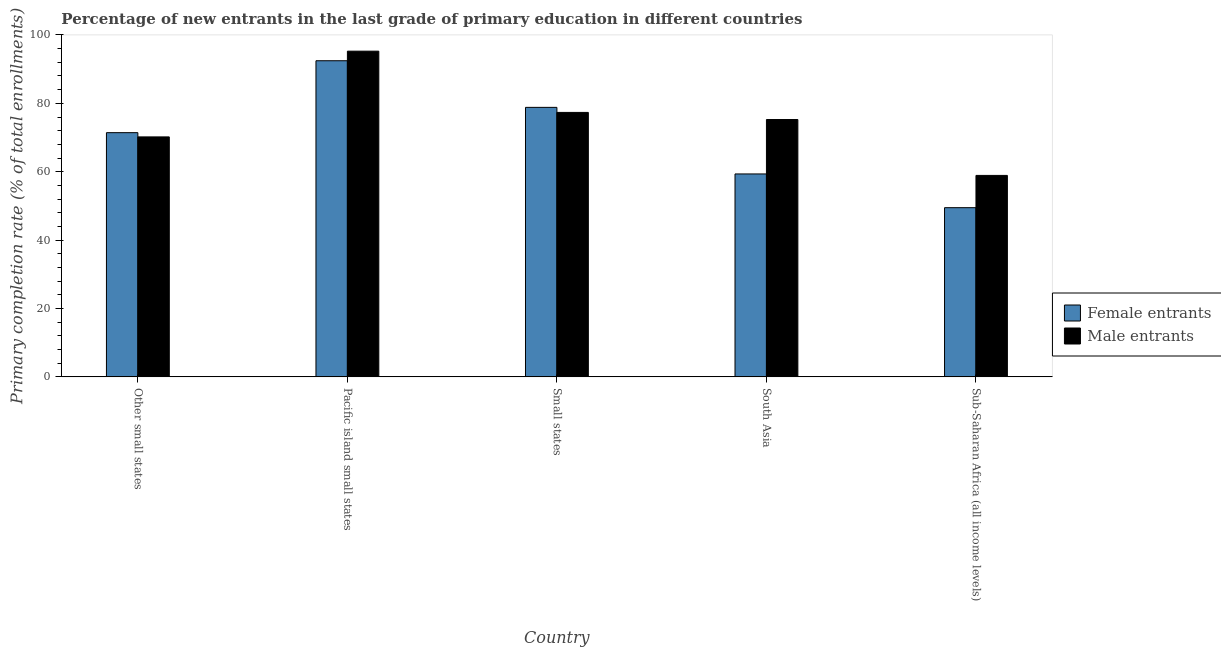How many different coloured bars are there?
Make the answer very short. 2. How many groups of bars are there?
Make the answer very short. 5. Are the number of bars per tick equal to the number of legend labels?
Keep it short and to the point. Yes. How many bars are there on the 1st tick from the left?
Your response must be concise. 2. How many bars are there on the 2nd tick from the right?
Provide a succinct answer. 2. What is the label of the 3rd group of bars from the left?
Offer a terse response. Small states. In how many cases, is the number of bars for a given country not equal to the number of legend labels?
Offer a very short reply. 0. What is the primary completion rate of male entrants in Other small states?
Offer a very short reply. 70.18. Across all countries, what is the maximum primary completion rate of male entrants?
Keep it short and to the point. 95.26. Across all countries, what is the minimum primary completion rate of male entrants?
Your answer should be very brief. 58.92. In which country was the primary completion rate of male entrants maximum?
Your response must be concise. Pacific island small states. In which country was the primary completion rate of female entrants minimum?
Provide a succinct answer. Sub-Saharan Africa (all income levels). What is the total primary completion rate of female entrants in the graph?
Ensure brevity in your answer.  351.53. What is the difference between the primary completion rate of female entrants in Other small states and that in Small states?
Make the answer very short. -7.39. What is the difference between the primary completion rate of female entrants in Small states and the primary completion rate of male entrants in Pacific island small states?
Your answer should be compact. -16.44. What is the average primary completion rate of male entrants per country?
Your answer should be compact. 75.39. What is the difference between the primary completion rate of male entrants and primary completion rate of female entrants in Other small states?
Ensure brevity in your answer.  -1.24. What is the ratio of the primary completion rate of male entrants in Other small states to that in South Asia?
Keep it short and to the point. 0.93. What is the difference between the highest and the second highest primary completion rate of male entrants?
Offer a very short reply. 17.91. What is the difference between the highest and the lowest primary completion rate of male entrants?
Provide a short and direct response. 36.34. In how many countries, is the primary completion rate of female entrants greater than the average primary completion rate of female entrants taken over all countries?
Ensure brevity in your answer.  3. Is the sum of the primary completion rate of female entrants in Other small states and Pacific island small states greater than the maximum primary completion rate of male entrants across all countries?
Your response must be concise. Yes. What does the 1st bar from the left in Small states represents?
Provide a succinct answer. Female entrants. What does the 1st bar from the right in Pacific island small states represents?
Your answer should be very brief. Male entrants. Are all the bars in the graph horizontal?
Provide a short and direct response. No. How many countries are there in the graph?
Your response must be concise. 5. What is the difference between two consecutive major ticks on the Y-axis?
Offer a terse response. 20. Are the values on the major ticks of Y-axis written in scientific E-notation?
Ensure brevity in your answer.  No. Does the graph contain grids?
Your answer should be very brief. No. Where does the legend appear in the graph?
Your answer should be very brief. Center right. How many legend labels are there?
Provide a succinct answer. 2. What is the title of the graph?
Give a very brief answer. Percentage of new entrants in the last grade of primary education in different countries. Does "Under-5(male)" appear as one of the legend labels in the graph?
Provide a succinct answer. No. What is the label or title of the X-axis?
Your answer should be compact. Country. What is the label or title of the Y-axis?
Your answer should be very brief. Primary completion rate (% of total enrollments). What is the Primary completion rate (% of total enrollments) in Female entrants in Other small states?
Ensure brevity in your answer.  71.42. What is the Primary completion rate (% of total enrollments) of Male entrants in Other small states?
Provide a succinct answer. 70.18. What is the Primary completion rate (% of total enrollments) of Female entrants in Pacific island small states?
Ensure brevity in your answer.  92.46. What is the Primary completion rate (% of total enrollments) in Male entrants in Pacific island small states?
Offer a very short reply. 95.26. What is the Primary completion rate (% of total enrollments) in Female entrants in Small states?
Keep it short and to the point. 78.82. What is the Primary completion rate (% of total enrollments) of Male entrants in Small states?
Your response must be concise. 77.35. What is the Primary completion rate (% of total enrollments) of Female entrants in South Asia?
Keep it short and to the point. 59.35. What is the Primary completion rate (% of total enrollments) in Male entrants in South Asia?
Offer a terse response. 75.27. What is the Primary completion rate (% of total enrollments) in Female entrants in Sub-Saharan Africa (all income levels)?
Give a very brief answer. 49.48. What is the Primary completion rate (% of total enrollments) in Male entrants in Sub-Saharan Africa (all income levels)?
Your response must be concise. 58.92. Across all countries, what is the maximum Primary completion rate (% of total enrollments) in Female entrants?
Offer a terse response. 92.46. Across all countries, what is the maximum Primary completion rate (% of total enrollments) in Male entrants?
Ensure brevity in your answer.  95.26. Across all countries, what is the minimum Primary completion rate (% of total enrollments) of Female entrants?
Give a very brief answer. 49.48. Across all countries, what is the minimum Primary completion rate (% of total enrollments) in Male entrants?
Offer a terse response. 58.92. What is the total Primary completion rate (% of total enrollments) in Female entrants in the graph?
Ensure brevity in your answer.  351.53. What is the total Primary completion rate (% of total enrollments) in Male entrants in the graph?
Ensure brevity in your answer.  376.97. What is the difference between the Primary completion rate (% of total enrollments) in Female entrants in Other small states and that in Pacific island small states?
Provide a succinct answer. -21.03. What is the difference between the Primary completion rate (% of total enrollments) in Male entrants in Other small states and that in Pacific island small states?
Ensure brevity in your answer.  -25.08. What is the difference between the Primary completion rate (% of total enrollments) of Female entrants in Other small states and that in Small states?
Give a very brief answer. -7.39. What is the difference between the Primary completion rate (% of total enrollments) in Male entrants in Other small states and that in Small states?
Provide a succinct answer. -7.16. What is the difference between the Primary completion rate (% of total enrollments) of Female entrants in Other small states and that in South Asia?
Your answer should be compact. 12.08. What is the difference between the Primary completion rate (% of total enrollments) of Male entrants in Other small states and that in South Asia?
Keep it short and to the point. -5.08. What is the difference between the Primary completion rate (% of total enrollments) in Female entrants in Other small states and that in Sub-Saharan Africa (all income levels)?
Offer a very short reply. 21.94. What is the difference between the Primary completion rate (% of total enrollments) in Male entrants in Other small states and that in Sub-Saharan Africa (all income levels)?
Keep it short and to the point. 11.26. What is the difference between the Primary completion rate (% of total enrollments) in Female entrants in Pacific island small states and that in Small states?
Make the answer very short. 13.64. What is the difference between the Primary completion rate (% of total enrollments) in Male entrants in Pacific island small states and that in Small states?
Your answer should be very brief. 17.91. What is the difference between the Primary completion rate (% of total enrollments) of Female entrants in Pacific island small states and that in South Asia?
Ensure brevity in your answer.  33.11. What is the difference between the Primary completion rate (% of total enrollments) in Male entrants in Pacific island small states and that in South Asia?
Provide a short and direct response. 19.99. What is the difference between the Primary completion rate (% of total enrollments) in Female entrants in Pacific island small states and that in Sub-Saharan Africa (all income levels)?
Your response must be concise. 42.97. What is the difference between the Primary completion rate (% of total enrollments) of Male entrants in Pacific island small states and that in Sub-Saharan Africa (all income levels)?
Provide a short and direct response. 36.34. What is the difference between the Primary completion rate (% of total enrollments) in Female entrants in Small states and that in South Asia?
Offer a very short reply. 19.47. What is the difference between the Primary completion rate (% of total enrollments) in Male entrants in Small states and that in South Asia?
Give a very brief answer. 2.08. What is the difference between the Primary completion rate (% of total enrollments) of Female entrants in Small states and that in Sub-Saharan Africa (all income levels)?
Provide a succinct answer. 29.33. What is the difference between the Primary completion rate (% of total enrollments) in Male entrants in Small states and that in Sub-Saharan Africa (all income levels)?
Make the answer very short. 18.43. What is the difference between the Primary completion rate (% of total enrollments) of Female entrants in South Asia and that in Sub-Saharan Africa (all income levels)?
Your answer should be very brief. 9.86. What is the difference between the Primary completion rate (% of total enrollments) of Male entrants in South Asia and that in Sub-Saharan Africa (all income levels)?
Ensure brevity in your answer.  16.35. What is the difference between the Primary completion rate (% of total enrollments) of Female entrants in Other small states and the Primary completion rate (% of total enrollments) of Male entrants in Pacific island small states?
Ensure brevity in your answer.  -23.84. What is the difference between the Primary completion rate (% of total enrollments) in Female entrants in Other small states and the Primary completion rate (% of total enrollments) in Male entrants in Small states?
Offer a very short reply. -5.92. What is the difference between the Primary completion rate (% of total enrollments) in Female entrants in Other small states and the Primary completion rate (% of total enrollments) in Male entrants in South Asia?
Provide a short and direct response. -3.84. What is the difference between the Primary completion rate (% of total enrollments) of Female entrants in Other small states and the Primary completion rate (% of total enrollments) of Male entrants in Sub-Saharan Africa (all income levels)?
Provide a short and direct response. 12.51. What is the difference between the Primary completion rate (% of total enrollments) in Female entrants in Pacific island small states and the Primary completion rate (% of total enrollments) in Male entrants in Small states?
Make the answer very short. 15.11. What is the difference between the Primary completion rate (% of total enrollments) of Female entrants in Pacific island small states and the Primary completion rate (% of total enrollments) of Male entrants in South Asia?
Offer a terse response. 17.19. What is the difference between the Primary completion rate (% of total enrollments) of Female entrants in Pacific island small states and the Primary completion rate (% of total enrollments) of Male entrants in Sub-Saharan Africa (all income levels)?
Your answer should be compact. 33.54. What is the difference between the Primary completion rate (% of total enrollments) of Female entrants in Small states and the Primary completion rate (% of total enrollments) of Male entrants in South Asia?
Ensure brevity in your answer.  3.55. What is the difference between the Primary completion rate (% of total enrollments) in Female entrants in Small states and the Primary completion rate (% of total enrollments) in Male entrants in Sub-Saharan Africa (all income levels)?
Your answer should be very brief. 19.9. What is the difference between the Primary completion rate (% of total enrollments) in Female entrants in South Asia and the Primary completion rate (% of total enrollments) in Male entrants in Sub-Saharan Africa (all income levels)?
Ensure brevity in your answer.  0.43. What is the average Primary completion rate (% of total enrollments) of Female entrants per country?
Make the answer very short. 70.31. What is the average Primary completion rate (% of total enrollments) in Male entrants per country?
Provide a short and direct response. 75.39. What is the difference between the Primary completion rate (% of total enrollments) in Female entrants and Primary completion rate (% of total enrollments) in Male entrants in Other small states?
Offer a very short reply. 1.24. What is the difference between the Primary completion rate (% of total enrollments) of Female entrants and Primary completion rate (% of total enrollments) of Male entrants in Pacific island small states?
Your answer should be very brief. -2.8. What is the difference between the Primary completion rate (% of total enrollments) of Female entrants and Primary completion rate (% of total enrollments) of Male entrants in Small states?
Offer a very short reply. 1.47. What is the difference between the Primary completion rate (% of total enrollments) of Female entrants and Primary completion rate (% of total enrollments) of Male entrants in South Asia?
Offer a terse response. -15.92. What is the difference between the Primary completion rate (% of total enrollments) of Female entrants and Primary completion rate (% of total enrollments) of Male entrants in Sub-Saharan Africa (all income levels)?
Provide a short and direct response. -9.43. What is the ratio of the Primary completion rate (% of total enrollments) of Female entrants in Other small states to that in Pacific island small states?
Make the answer very short. 0.77. What is the ratio of the Primary completion rate (% of total enrollments) in Male entrants in Other small states to that in Pacific island small states?
Provide a short and direct response. 0.74. What is the ratio of the Primary completion rate (% of total enrollments) in Female entrants in Other small states to that in Small states?
Ensure brevity in your answer.  0.91. What is the ratio of the Primary completion rate (% of total enrollments) in Male entrants in Other small states to that in Small states?
Offer a terse response. 0.91. What is the ratio of the Primary completion rate (% of total enrollments) in Female entrants in Other small states to that in South Asia?
Make the answer very short. 1.2. What is the ratio of the Primary completion rate (% of total enrollments) in Male entrants in Other small states to that in South Asia?
Offer a terse response. 0.93. What is the ratio of the Primary completion rate (% of total enrollments) of Female entrants in Other small states to that in Sub-Saharan Africa (all income levels)?
Ensure brevity in your answer.  1.44. What is the ratio of the Primary completion rate (% of total enrollments) of Male entrants in Other small states to that in Sub-Saharan Africa (all income levels)?
Provide a succinct answer. 1.19. What is the ratio of the Primary completion rate (% of total enrollments) in Female entrants in Pacific island small states to that in Small states?
Your response must be concise. 1.17. What is the ratio of the Primary completion rate (% of total enrollments) of Male entrants in Pacific island small states to that in Small states?
Keep it short and to the point. 1.23. What is the ratio of the Primary completion rate (% of total enrollments) in Female entrants in Pacific island small states to that in South Asia?
Give a very brief answer. 1.56. What is the ratio of the Primary completion rate (% of total enrollments) in Male entrants in Pacific island small states to that in South Asia?
Your answer should be compact. 1.27. What is the ratio of the Primary completion rate (% of total enrollments) in Female entrants in Pacific island small states to that in Sub-Saharan Africa (all income levels)?
Your answer should be very brief. 1.87. What is the ratio of the Primary completion rate (% of total enrollments) in Male entrants in Pacific island small states to that in Sub-Saharan Africa (all income levels)?
Ensure brevity in your answer.  1.62. What is the ratio of the Primary completion rate (% of total enrollments) in Female entrants in Small states to that in South Asia?
Provide a short and direct response. 1.33. What is the ratio of the Primary completion rate (% of total enrollments) of Male entrants in Small states to that in South Asia?
Offer a terse response. 1.03. What is the ratio of the Primary completion rate (% of total enrollments) of Female entrants in Small states to that in Sub-Saharan Africa (all income levels)?
Your response must be concise. 1.59. What is the ratio of the Primary completion rate (% of total enrollments) of Male entrants in Small states to that in Sub-Saharan Africa (all income levels)?
Keep it short and to the point. 1.31. What is the ratio of the Primary completion rate (% of total enrollments) of Female entrants in South Asia to that in Sub-Saharan Africa (all income levels)?
Keep it short and to the point. 1.2. What is the ratio of the Primary completion rate (% of total enrollments) in Male entrants in South Asia to that in Sub-Saharan Africa (all income levels)?
Your answer should be compact. 1.28. What is the difference between the highest and the second highest Primary completion rate (% of total enrollments) of Female entrants?
Ensure brevity in your answer.  13.64. What is the difference between the highest and the second highest Primary completion rate (% of total enrollments) in Male entrants?
Provide a short and direct response. 17.91. What is the difference between the highest and the lowest Primary completion rate (% of total enrollments) in Female entrants?
Keep it short and to the point. 42.97. What is the difference between the highest and the lowest Primary completion rate (% of total enrollments) in Male entrants?
Provide a succinct answer. 36.34. 